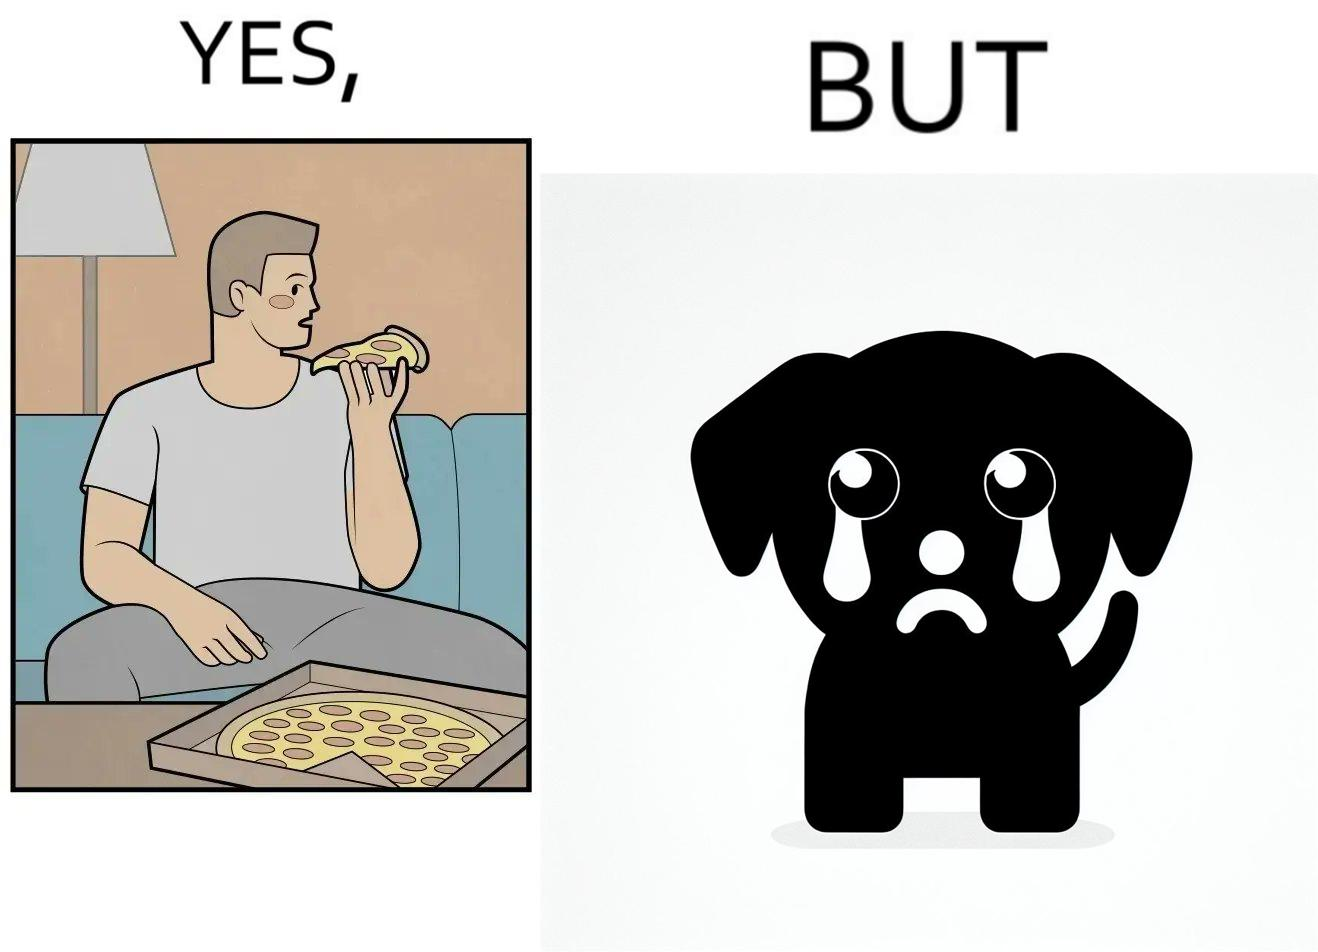Describe the contrast between the left and right parts of this image. In the left part of the image: It is a man eating a pizza In the right part of the image: It is a pet dog with teary eyes 